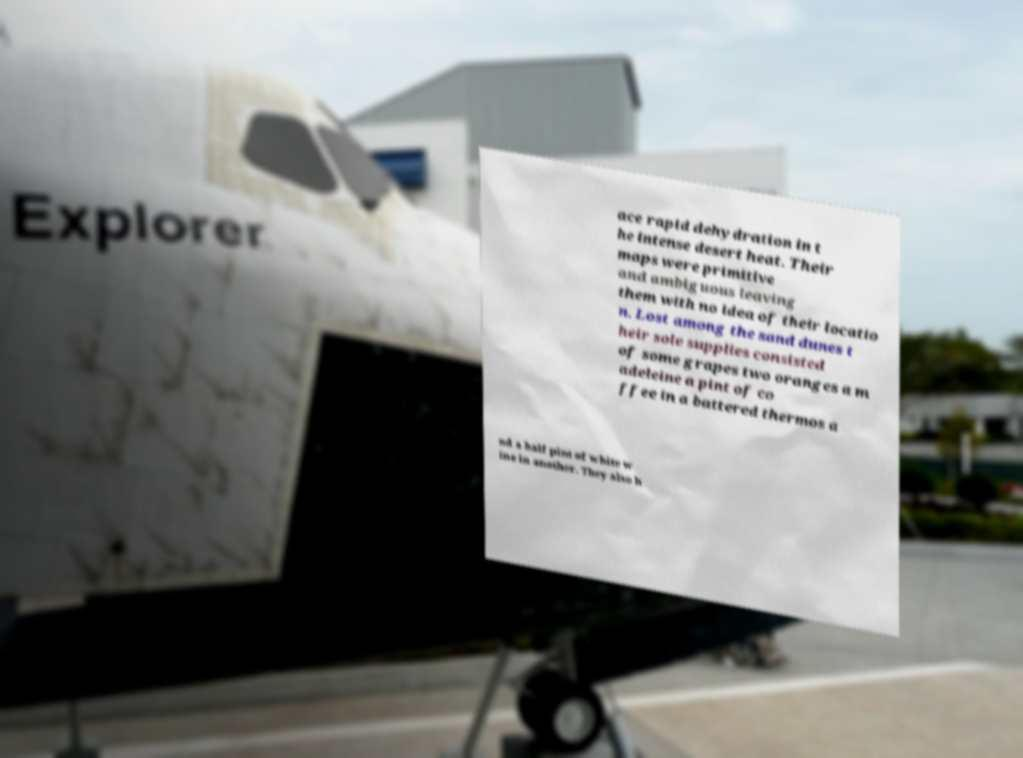Could you assist in decoding the text presented in this image and type it out clearly? ace rapid dehydration in t he intense desert heat. Their maps were primitive and ambiguous leaving them with no idea of their locatio n. Lost among the sand dunes t heir sole supplies consisted of some grapes two oranges a m adeleine a pint of co ffee in a battered thermos a nd a half pint of white w ine in another. They also h 